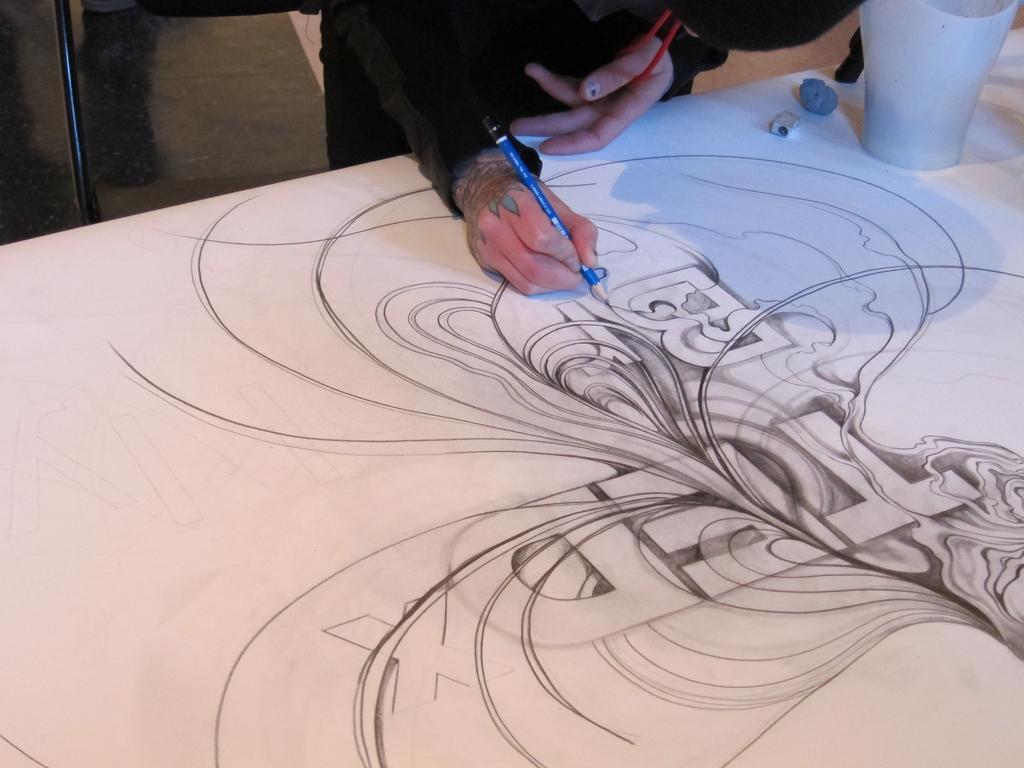Can you describe this image briefly? In this image, we can see a human is holding a pencil and drawing some object on the white surface. Here we can see tattoo. Top of the image, we can see floor, rod, few objects. 